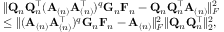<formula> <loc_0><loc_0><loc_500><loc_500>\begin{array} { r l } & { \| Q _ { n } Q _ { n } ^ { \top } ( A _ { ( n ) } A _ { ( n ) } ^ { \top } ) ^ { q } G _ { n } F _ { n } - Q _ { n } Q _ { n } ^ { \top } A _ { ( n ) } \| _ { F } ^ { 2 } } \\ & { \leq \| ( A _ { ( n ) } A _ { ( n ) } ^ { \top } ) ^ { q } G _ { n } F _ { n } - A _ { ( n ) } \| _ { F } ^ { 2 } \| Q _ { n } Q _ { n } ^ { \top } \| _ { 2 } ^ { 2 } , } \end{array}</formula> 